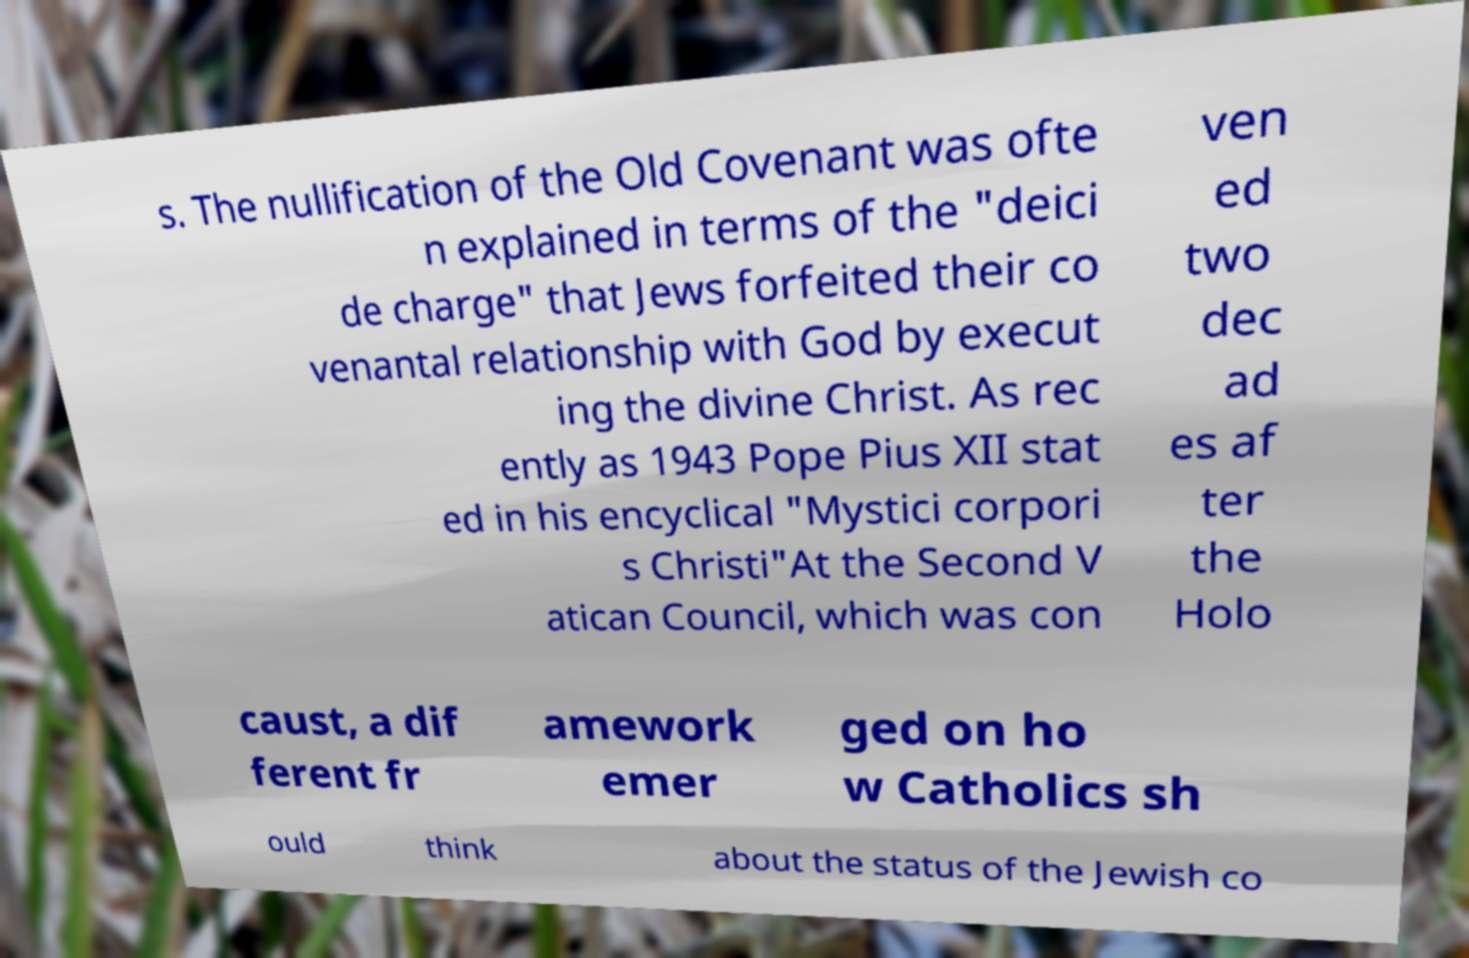For documentation purposes, I need the text within this image transcribed. Could you provide that? s. The nullification of the Old Covenant was ofte n explained in terms of the "deici de charge" that Jews forfeited their co venantal relationship with God by execut ing the divine Christ. As rec ently as 1943 Pope Pius XII stat ed in his encyclical "Mystici corpori s Christi"At the Second V atican Council, which was con ven ed two dec ad es af ter the Holo caust, a dif ferent fr amework emer ged on ho w Catholics sh ould think about the status of the Jewish co 